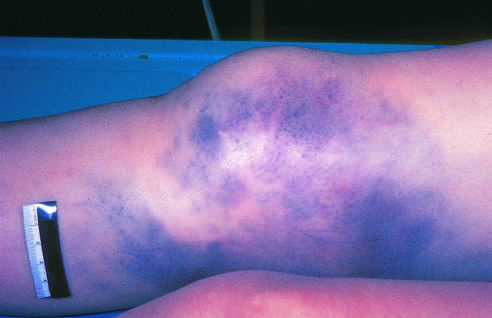what has produced extensive discoloration?
Answer the question using a single word or phrase. Hemorrhage of subcutaneous vessels 